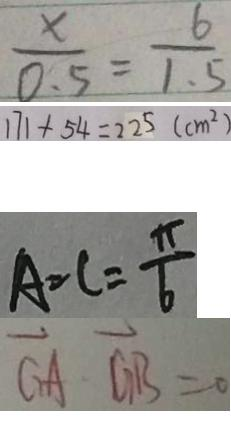<formula> <loc_0><loc_0><loc_500><loc_500>\frac { x } { 0 . 5 } = \frac { 6 } { 1 . 5 } 
 1 7 1 + 5 4 = 2 2 5 ( c m ^ { 2 } ) 
 A = C = \frac { \pi } { 6 } 
 \overrightarrow { G A } \cdot \overrightarrow { G B } = 0</formula> 